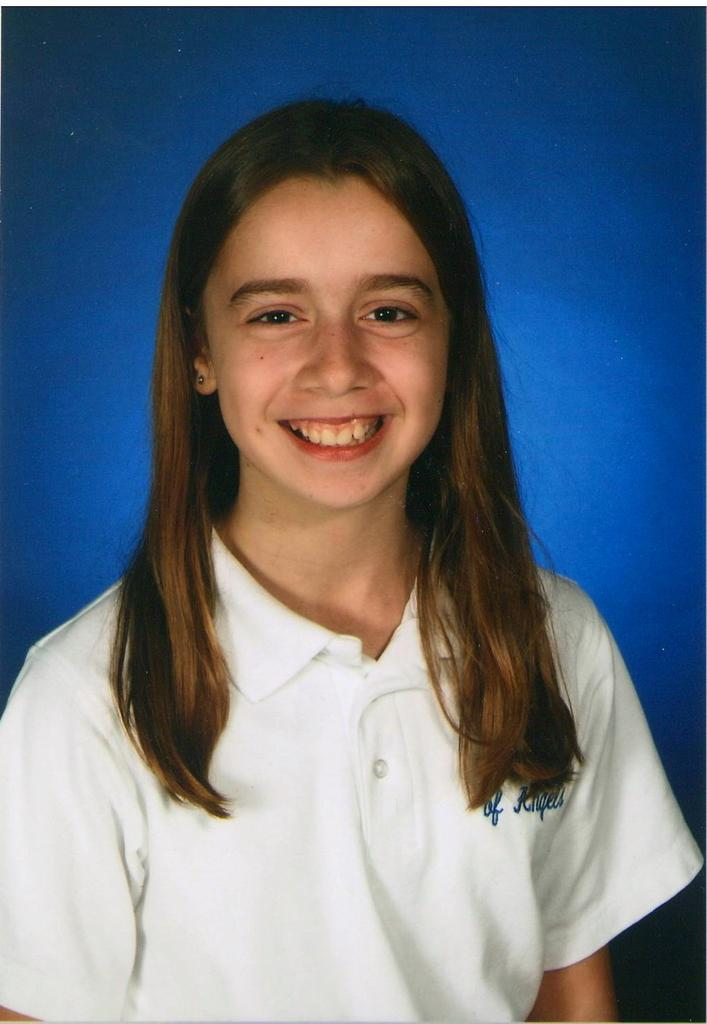Who is present in the image? There is a woman in the image. What is the woman wearing? The woman is wearing a white t-shirt. What expression does the woman have? The woman is smiling. What color can be seen in the background of the image? There is a blue color visible in the background of the image. What achievement is the woman celebrating in the image? There is no indication in the image that the woman is celebrating any achievement. 